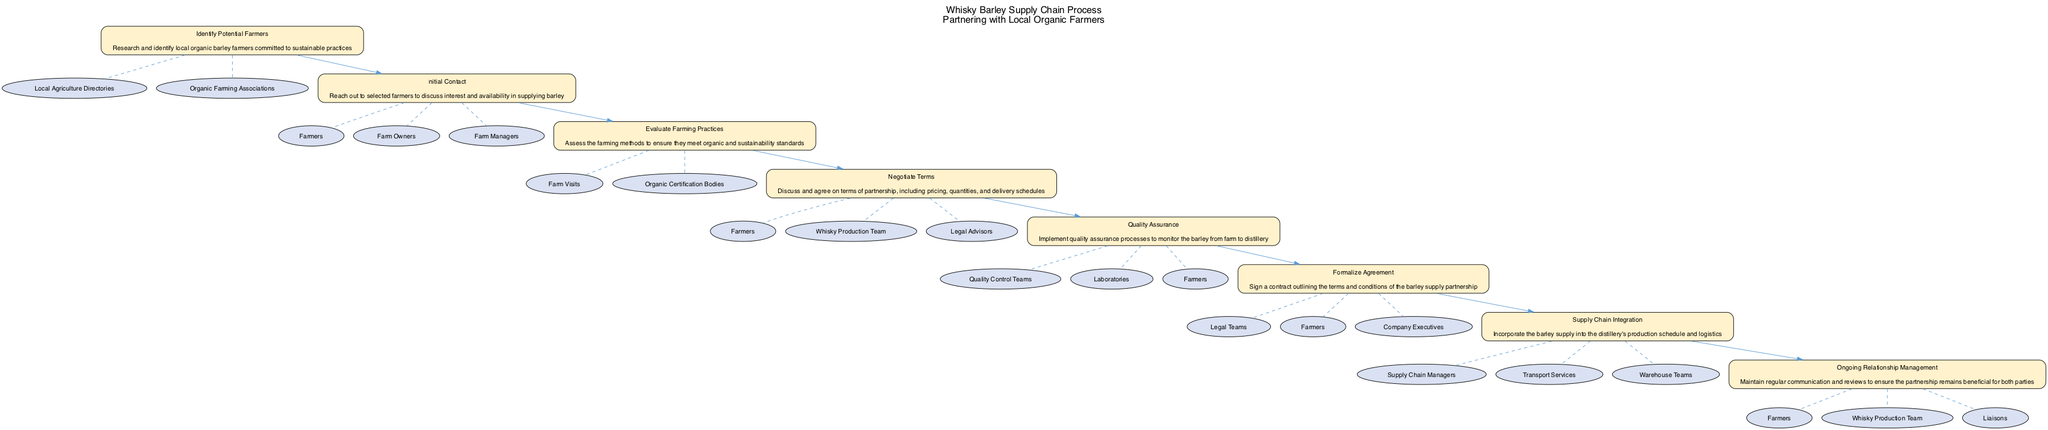What is the first step in the diagram? The diagram starts with the first step labeled "Identify Potential Farmers," indicating that this is the initial action in the supply chain process.
Answer: Identify Potential Farmers How many steps are involved in the process? By counting the steps represented in the diagram, there are eight distinct steps listed from identifying farmers to ongoing relationship management.
Answer: 8 Which entities are associated with the "Negotiate Terms" step? The "Negotiate Terms" step has three associated entities: Farmers, Whisky Production Team, and Legal Advisors, which provide support during this stage of the partnership.
Answer: Farmers, Whisky Production Team, Legal Advisors What step follows "Evaluate Farming Practices"? According to the flow of the diagram, "Negotiate Terms" directly follows "Evaluate Farming Practices," indicating a sequence in the process of partnering with farmers.
Answer: Negotiate Terms Which step involves the quality assurance processes? The step clearly labeled "Quality Assurance" is dedicated to implementing processes to monitor the barley from the farm to the distillery, focusing on maintaining quality standards.
Answer: Quality Assurance What is the role of "Supply Chain Managers"? "Supply Chain Managers" play a crucial role during the step titled "Supply Chain Integration," as they are responsible for incorporating the barley supply into the distillery’s production schedule and logistics.
Answer: Supply Chain Integration How is the ongoing relationship managed according to the diagram? The diagram specifies "Ongoing Relationship Management" as the step where regular communication and reviews are conducted to ensure a beneficial partnership for both parties.
Answer: Ongoing Relationship Management What shape represents the steps in the diagram? In the diagram, all steps are represented in boxes, which signify the various actions or stages involved in the partnership process with local organic farmers.
Answer: Box What type of relationship exists between "Negotiate Terms" and "Quality Assurance"? The relationship is sequential as "Negotiate Terms" occurs before "Quality Assurance," indicating that negotiation must happen before quality processes are implemented.
Answer: Sequential 